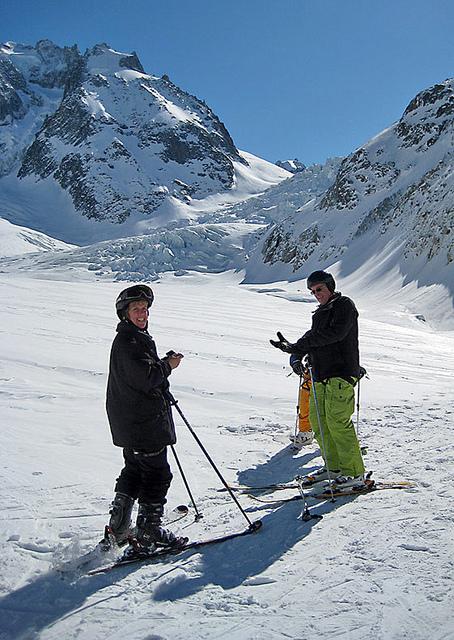Are both men wearing hats?
Short answer required. Yes. How many people in the photo?
Be succinct. 2. What is covering the man's eyes?
Write a very short answer. Sunglasses. Is the person on the left a man or woman?
Short answer required. Woman. What color is the jacket on the left?
Short answer required. Black. 